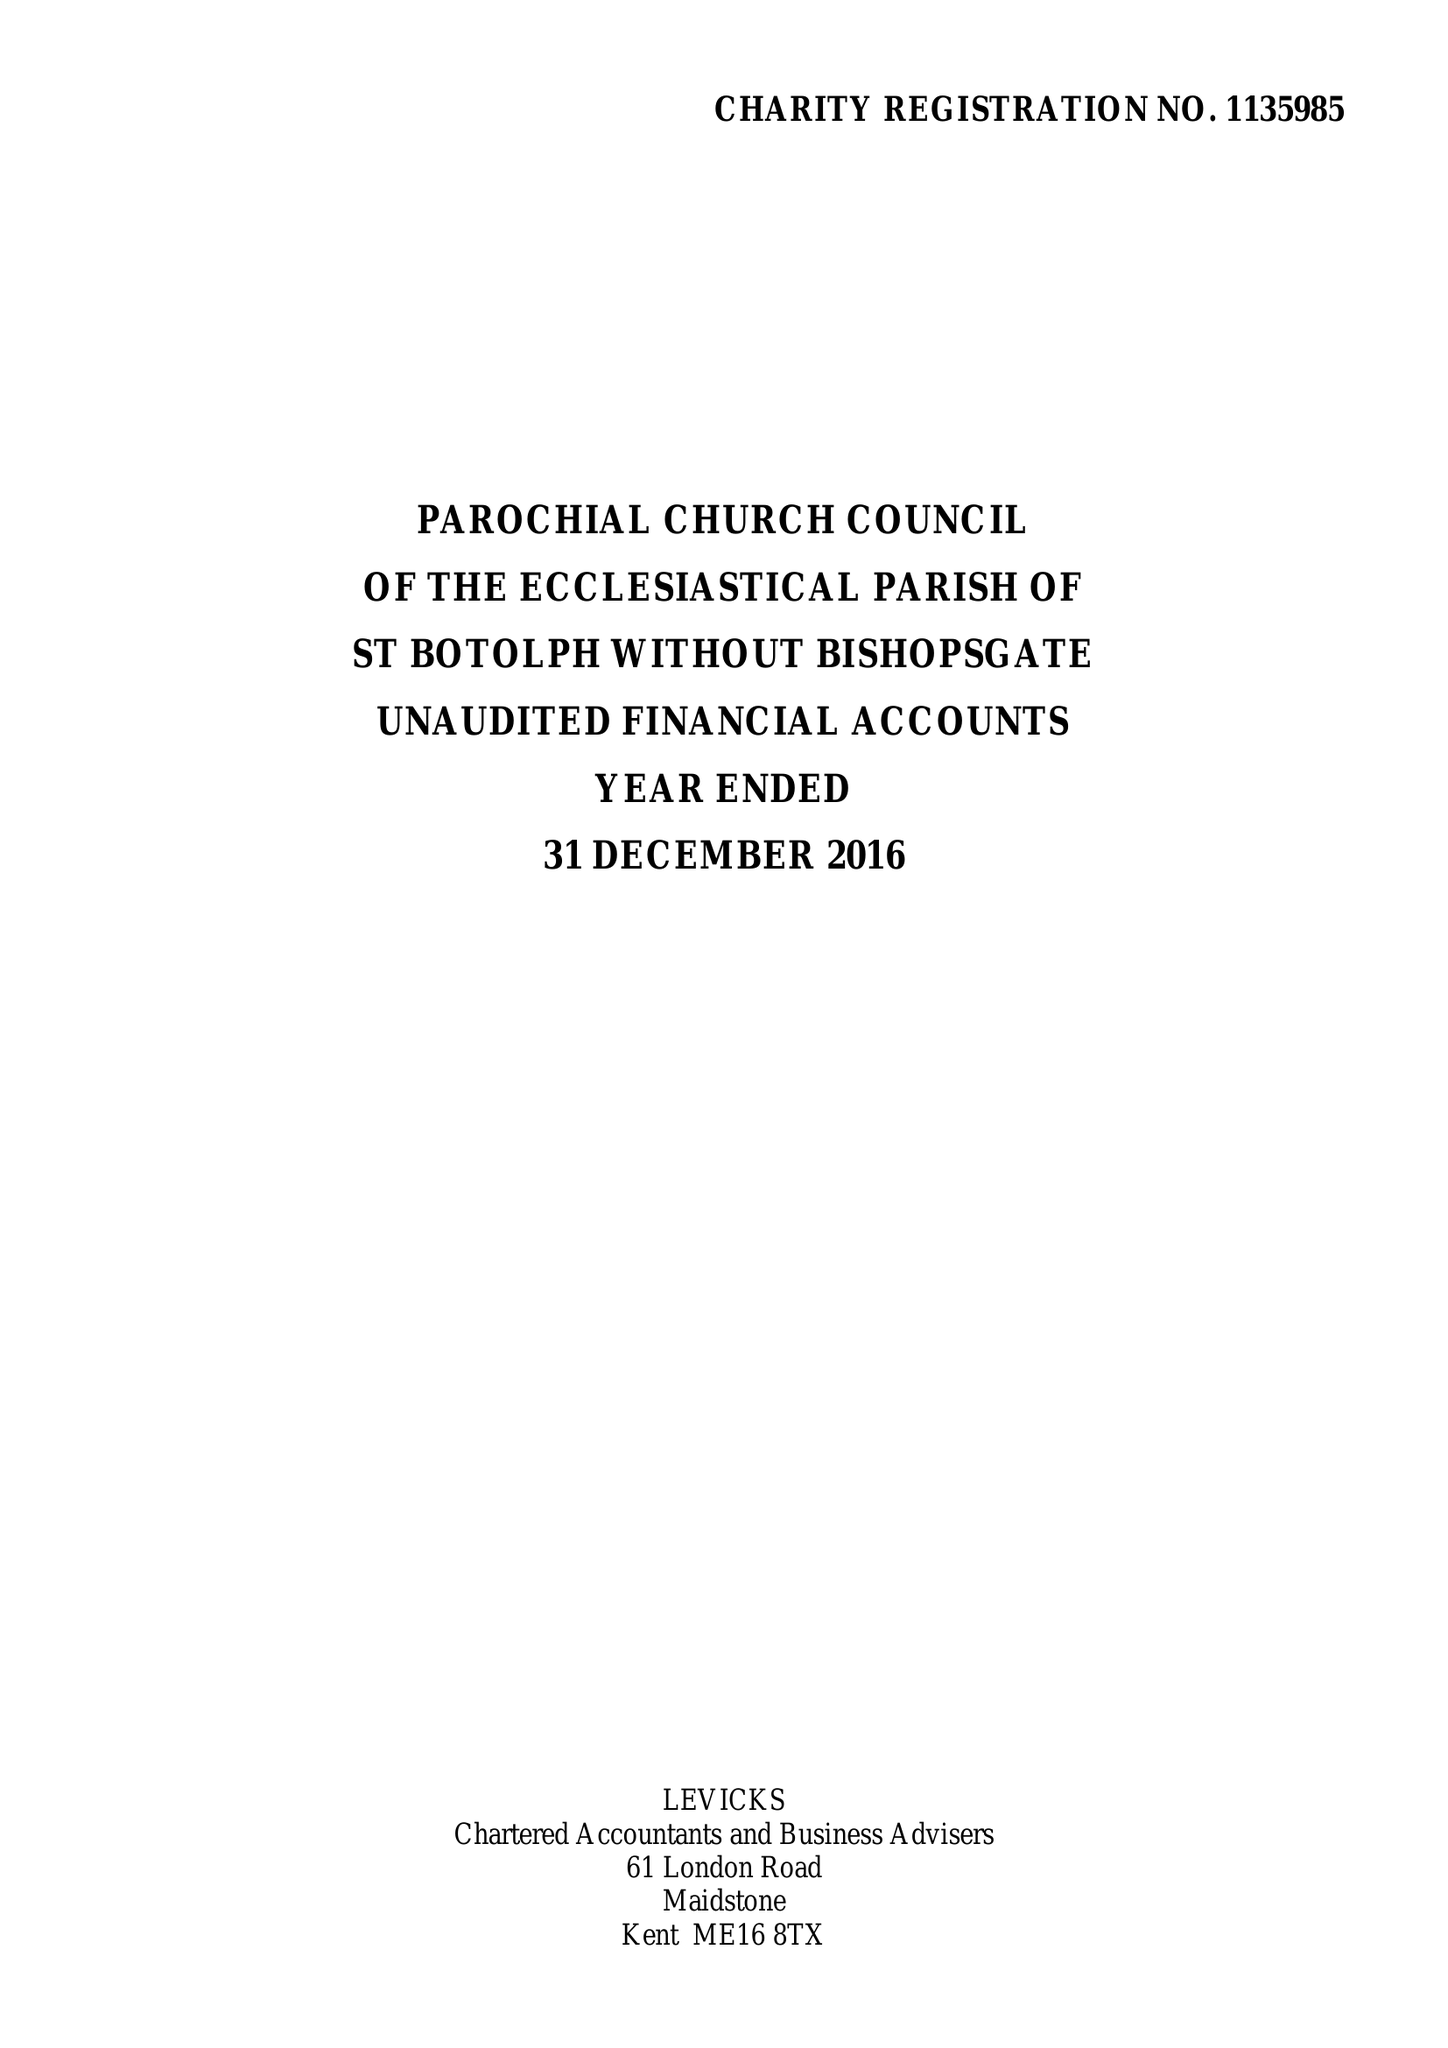What is the value for the report_date?
Answer the question using a single word or phrase. 2016-12-31 